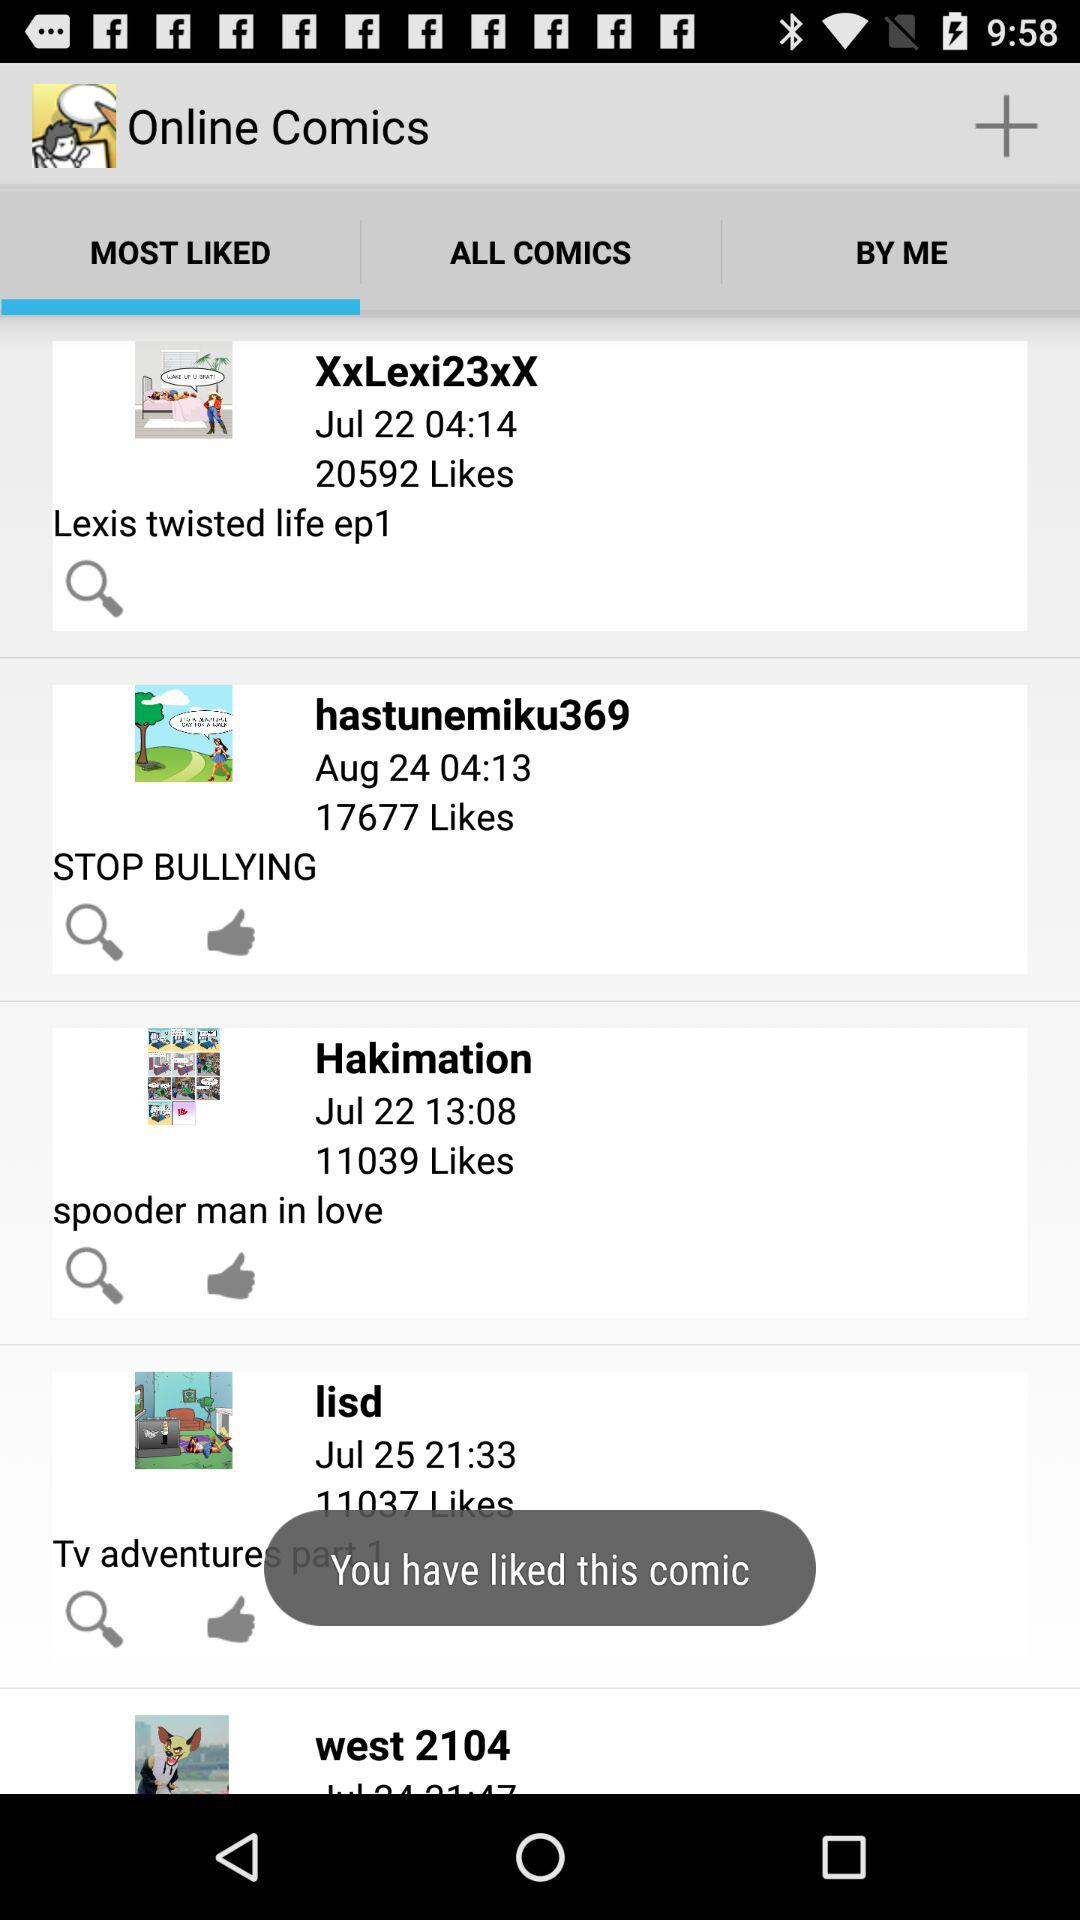How many likes did "Hakimation" get? "Hakimation" gets 11039 likes. 